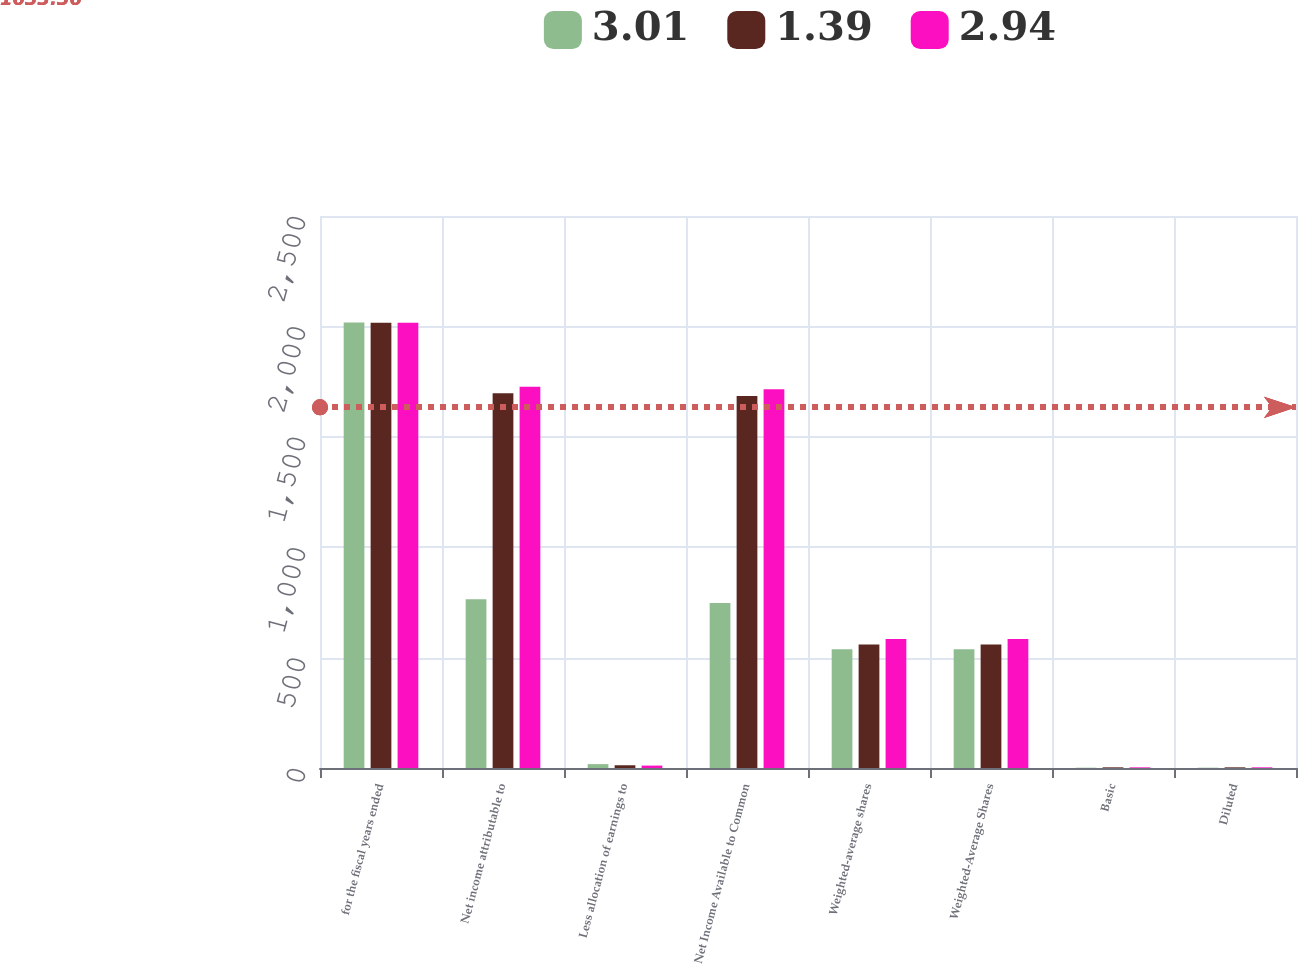Convert chart. <chart><loc_0><loc_0><loc_500><loc_500><stacked_bar_chart><ecel><fcel>for the fiscal years ended<fcel>Net income attributable to<fcel>Less allocation of earnings to<fcel>Net Income Available to Common<fcel>Weighted-average shares<fcel>Weighted-Average Shares<fcel>Basic<fcel>Diluted<nl><fcel>3.01<fcel>2018<fcel>764.4<fcel>17.6<fcel>746.8<fcel>537.4<fcel>538<fcel>1.39<fcel>1.39<nl><fcel>1.39<fcel>2017<fcel>1696.7<fcel>12.4<fcel>1684.3<fcel>558.8<fcel>559.1<fcel>3.01<fcel>3.01<nl><fcel>2.94<fcel>2016<fcel>1726.7<fcel>10.9<fcel>1715.8<fcel>583.8<fcel>583.8<fcel>2.94<fcel>2.94<nl></chart> 